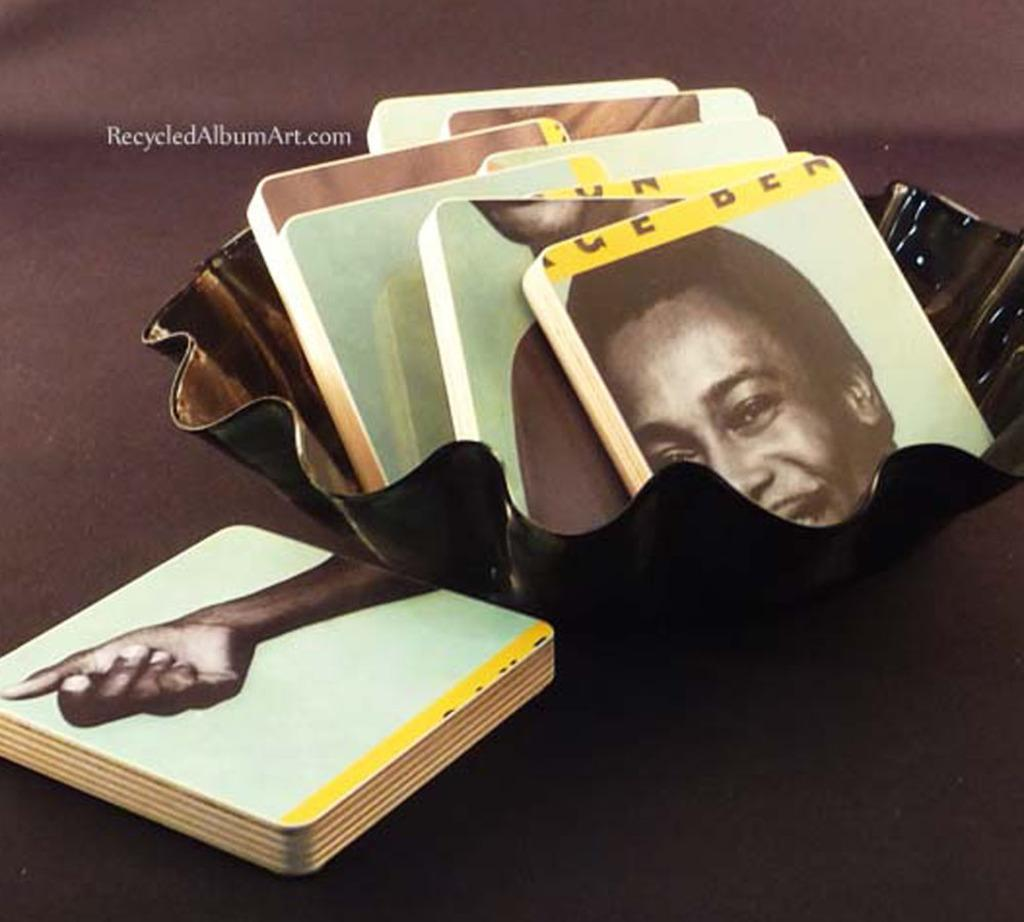What objects are present in the image? There are boards, a bowl, and a watermark in the image. What is depicted on the boards? A face and a hand of a person are depicted on the boards. What is the purpose of the bowl in the image? The purpose of the bowl is not specified in the image, but it could be used for holding or serving something. What is the watermark in the image? The watermark is a mark or symbol that indicates the ownership or origin of the image. How many babies are crawling on the boards in the image? There are no babies present in the image; it only depicts a face and a hand of a person on the boards. What type of nut is being cracked open by the person in the image? There is no nut or person present in the image; it only depicts a face and a hand of a person on the boards. 